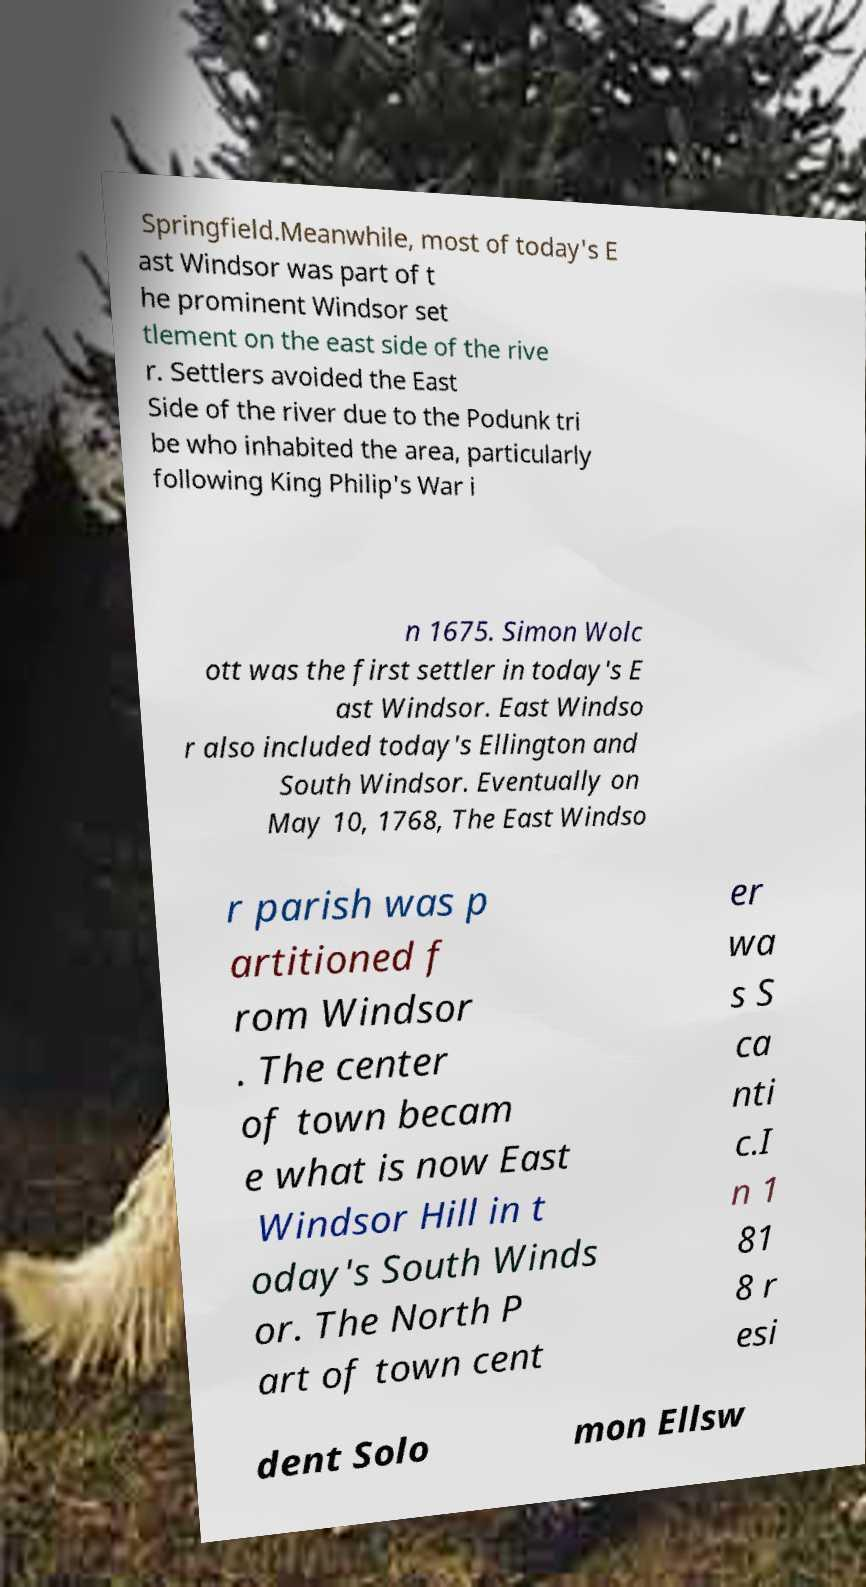There's text embedded in this image that I need extracted. Can you transcribe it verbatim? Springfield.Meanwhile, most of today's E ast Windsor was part of t he prominent Windsor set tlement on the east side of the rive r. Settlers avoided the East Side of the river due to the Podunk tri be who inhabited the area, particularly following King Philip's War i n 1675. Simon Wolc ott was the first settler in today's E ast Windsor. East Windso r also included today's Ellington and South Windsor. Eventually on May 10, 1768, The East Windso r parish was p artitioned f rom Windsor . The center of town becam e what is now East Windsor Hill in t oday's South Winds or. The North P art of town cent er wa s S ca nti c.I n 1 81 8 r esi dent Solo mon Ellsw 